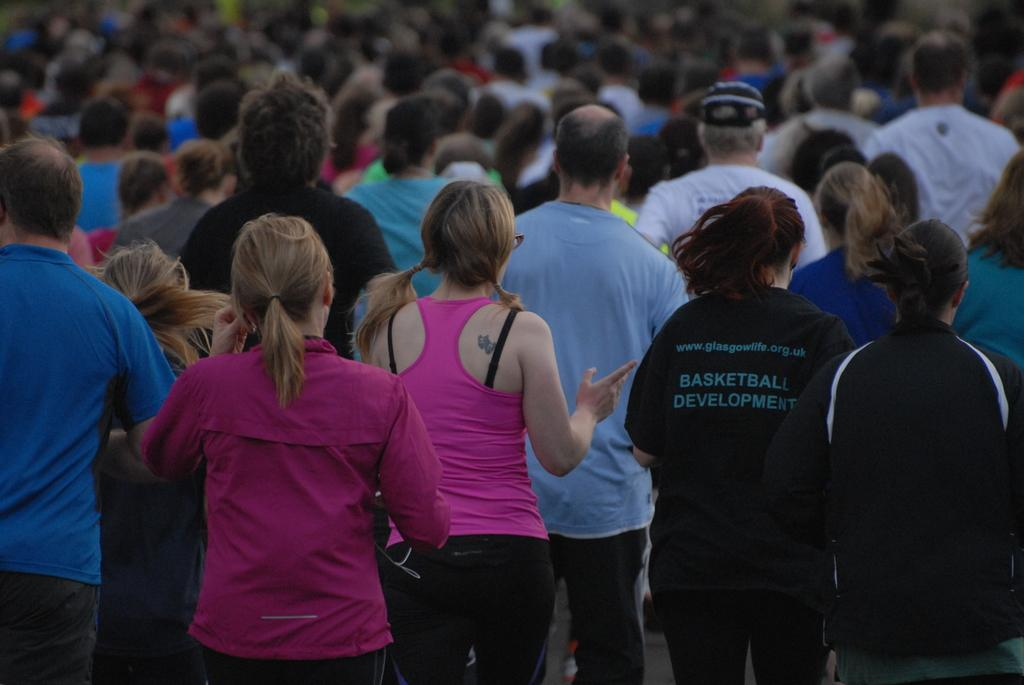What types of people can be seen in the image? There are men and women in the image. What are the men and women doing in the image? The men and women are walking. What are the men and women wearing in the image? The men and women are wearing clothes. What type of cork can be seen in the image? There is no cork present in the image. What kind of curve can be seen in the image? There is no curve present in the image. 